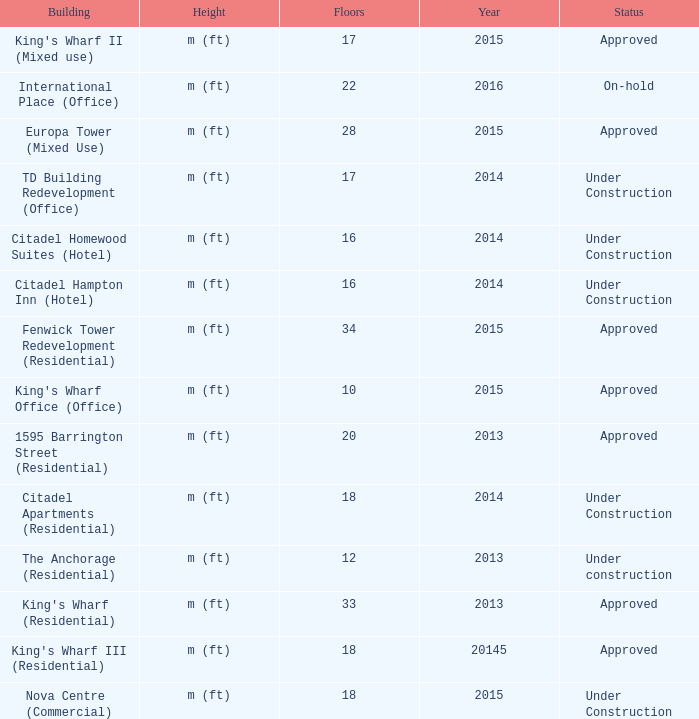What is the status of the building with more than 28 floor and a year of 2013? Approved. 